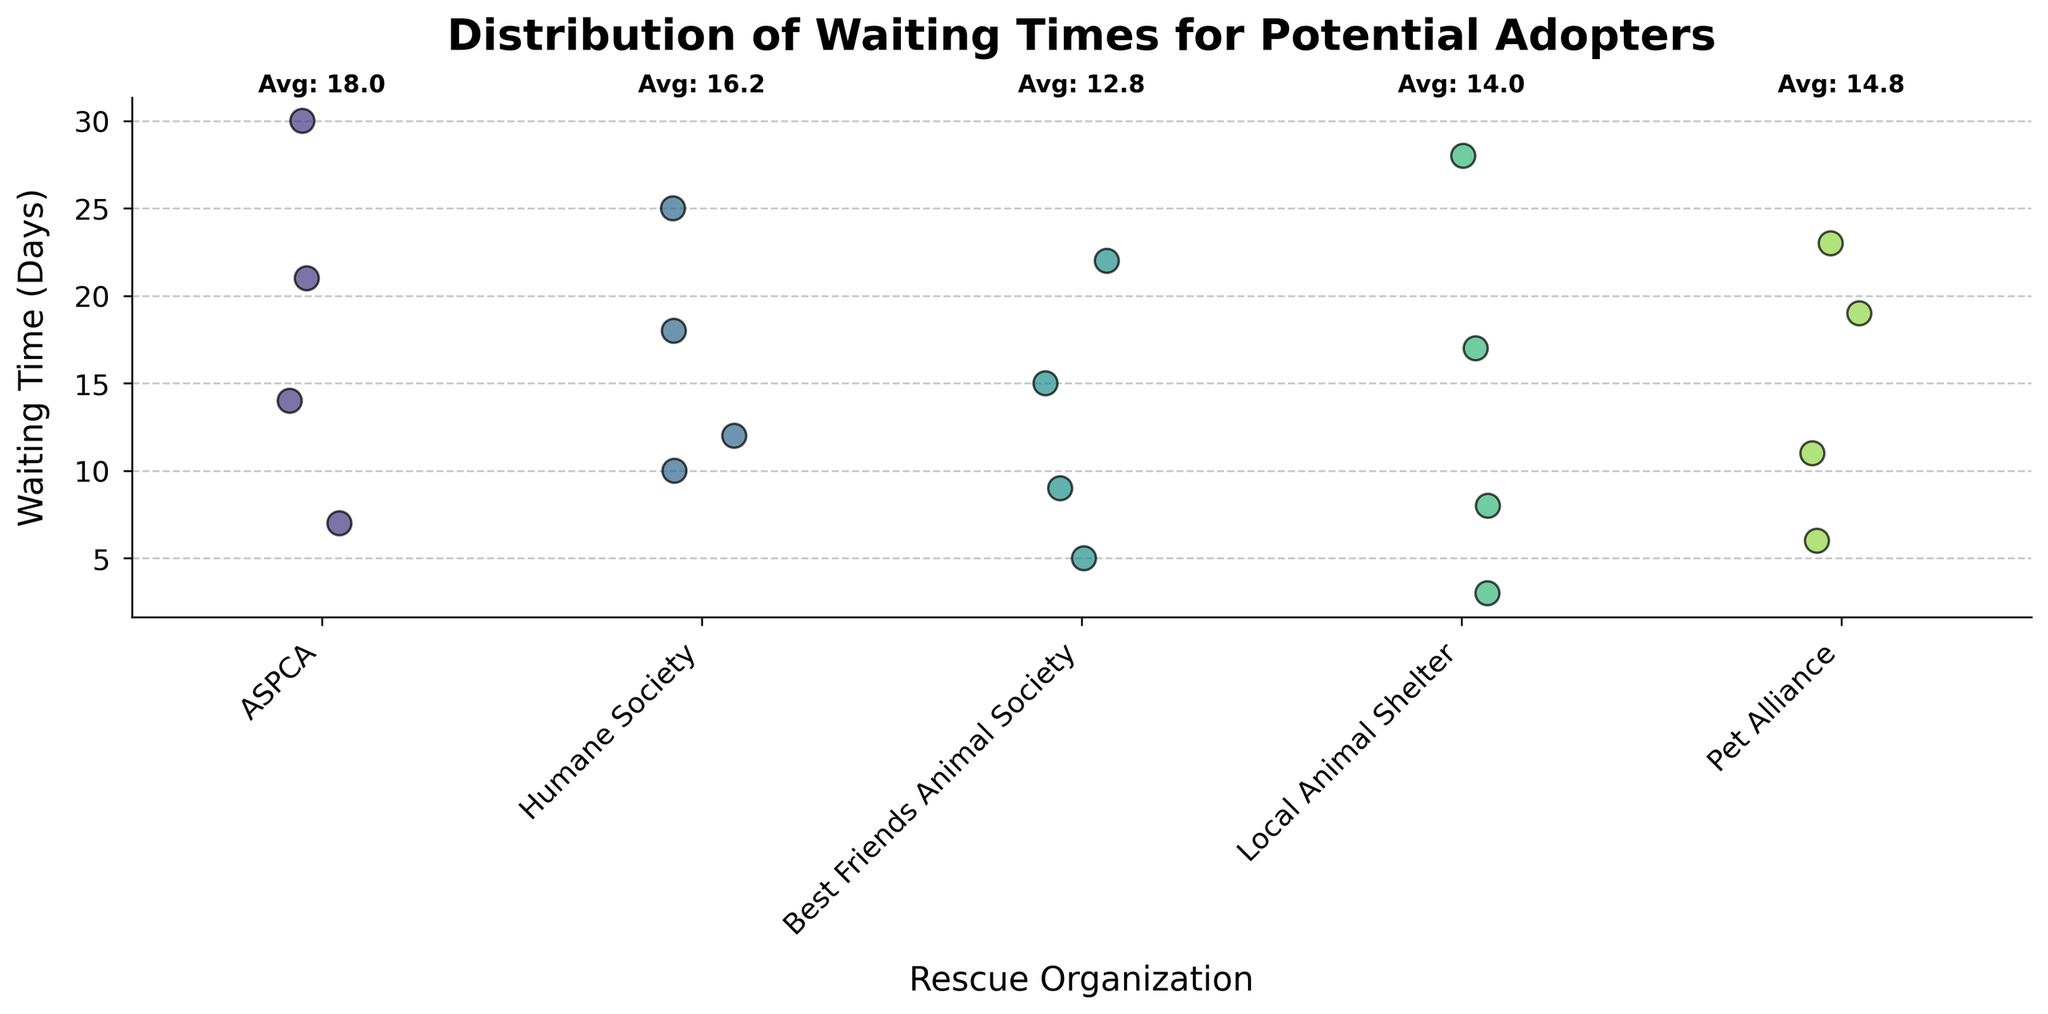What is the title of the plot? The title can be found at the top of the plot, and it is typically bold and in a larger font size. The title provides a brief summary of what the plot shows.
Answer: Distribution of Waiting Times for Potential Adopters How many organizations are represented in the plot? Count the number of distinct labels on the x-axis, where each label represents a unique rescue organization.
Answer: 5 Which rescue organization has the shortest waiting time? By looking at the y-axis and locating the lowest data point for each organization, you can identify the organization associated with the minimum value.
Answer: Local Animal Shelter Which rescue organization has the longest waiting time? By looking at the y-axis and locating the highest data point for each organization, you can identify the organization associated with the maximum value.
Answer: ASPCA What is the average waiting time for the ASPCA? The average is indicated for each organization above the plot area, calculated as the mean of waiting times for ASPCA.
Answer: 18.0 Which rescue organization has the highest average waiting time? Compare the average waiting times noted above each organization on the plot and select the highest one.
Answer: ASPCA How does the average waiting time of the Local Animal Shelter compare to the Best Friends Animal Society? Look at the average waiting times shown above both organizations and compare them.
Answer: Local Animal Shelter's average waiting time is higher Are there any rescue organizations with a waiting time below 5 days? Check the y-axis and see if any data points along each organization fall below the 5-day mark.
Answer: Yes What is the range of waiting times for the Best Friends Animal Society? Identify the maximum and minimum waiting times for the organization and subtract the minimum from the maximum.
Answer: 22 - 5 = 17 days Which rescue organization appears to have the most variability in waiting times? Determine variability by observing the spread of data points for each organization on the y-axis. The more dispersed the points are, the higher the variability.
Answer: ASPCA 